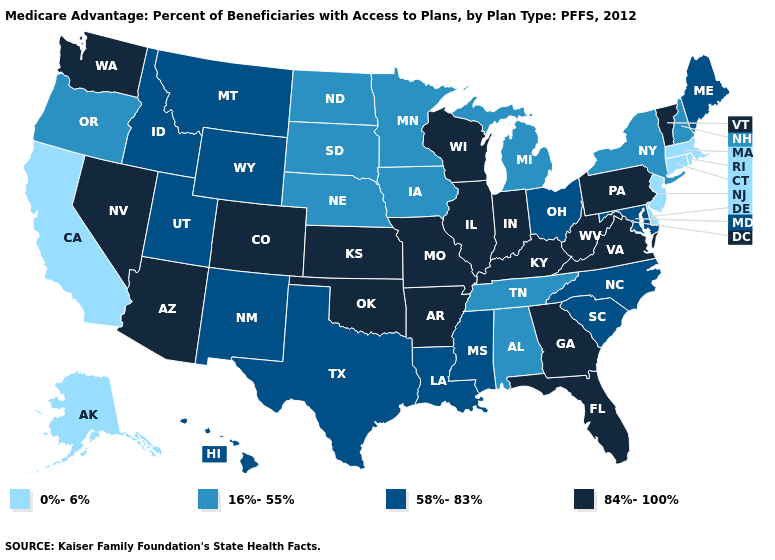Which states have the highest value in the USA?
Be succinct. Arkansas, Arizona, Colorado, Florida, Georgia, Illinois, Indiana, Kansas, Kentucky, Missouri, Nevada, Oklahoma, Pennsylvania, Virginia, Vermont, Washington, Wisconsin, West Virginia. Name the states that have a value in the range 16%-55%?
Be succinct. Alabama, Iowa, Michigan, Minnesota, North Dakota, Nebraska, New Hampshire, New York, Oregon, South Dakota, Tennessee. What is the value of Massachusetts?
Quick response, please. 0%-6%. What is the value of Ohio?
Write a very short answer. 58%-83%. Does Montana have a lower value than Kansas?
Quick response, please. Yes. Name the states that have a value in the range 84%-100%?
Quick response, please. Arkansas, Arizona, Colorado, Florida, Georgia, Illinois, Indiana, Kansas, Kentucky, Missouri, Nevada, Oklahoma, Pennsylvania, Virginia, Vermont, Washington, Wisconsin, West Virginia. Among the states that border Michigan , which have the highest value?
Concise answer only. Indiana, Wisconsin. Name the states that have a value in the range 16%-55%?
Keep it brief. Alabama, Iowa, Michigan, Minnesota, North Dakota, Nebraska, New Hampshire, New York, Oregon, South Dakota, Tennessee. What is the value of Pennsylvania?
Keep it brief. 84%-100%. Which states have the lowest value in the USA?
Quick response, please. Alaska, California, Connecticut, Delaware, Massachusetts, New Jersey, Rhode Island. Which states have the lowest value in the South?
Answer briefly. Delaware. Among the states that border Washington , which have the highest value?
Give a very brief answer. Idaho. What is the highest value in states that border Tennessee?
Answer briefly. 84%-100%. Which states have the lowest value in the USA?
Answer briefly. Alaska, California, Connecticut, Delaware, Massachusetts, New Jersey, Rhode Island. What is the highest value in states that border Oklahoma?
Be succinct. 84%-100%. 